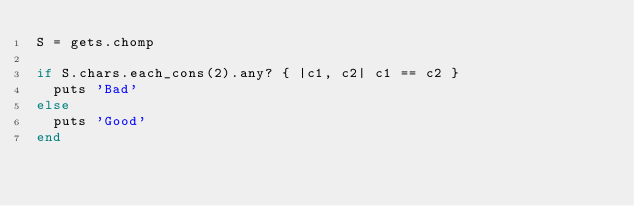Convert code to text. <code><loc_0><loc_0><loc_500><loc_500><_Ruby_>S = gets.chomp

if S.chars.each_cons(2).any? { |c1, c2| c1 == c2 }
  puts 'Bad'
else
  puts 'Good'
end
</code> 